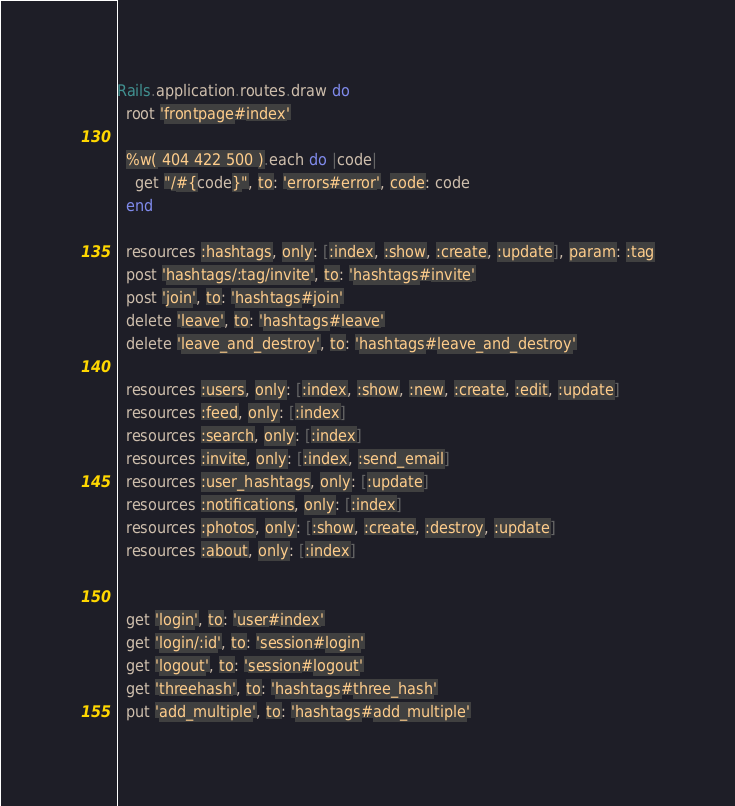<code> <loc_0><loc_0><loc_500><loc_500><_Ruby_>Rails.application.routes.draw do
  root 'frontpage#index'

  %w( 404 422 500 ).each do |code|
    get "/#{code}", to: 'errors#error', code: code
  end

  resources :hashtags, only: [:index, :show, :create, :update], param: :tag
  post 'hashtags/:tag/invite', to: 'hashtags#invite'
  post 'join', to: 'hashtags#join'
  delete 'leave', to: 'hashtags#leave'
  delete 'leave_and_destroy', to: 'hashtags#leave_and_destroy'

  resources :users, only: [:index, :show, :new, :create, :edit, :update]
  resources :feed, only: [:index]
  resources :search, only: [:index]
  resources :invite, only: [:index, :send_email]
  resources :user_hashtags, only: [:update]
  resources :notifications, only: [:index]
  resources :photos, only: [:show, :create, :destroy, :update]
  resources :about, only: [:index]


  get 'login', to: 'user#index'
  get 'login/:id', to: 'session#login'
  get 'logout', to: 'session#logout'
  get 'threehash', to: 'hashtags#three_hash'
  put 'add_multiple', to: 'hashtags#add_multiple'</code> 